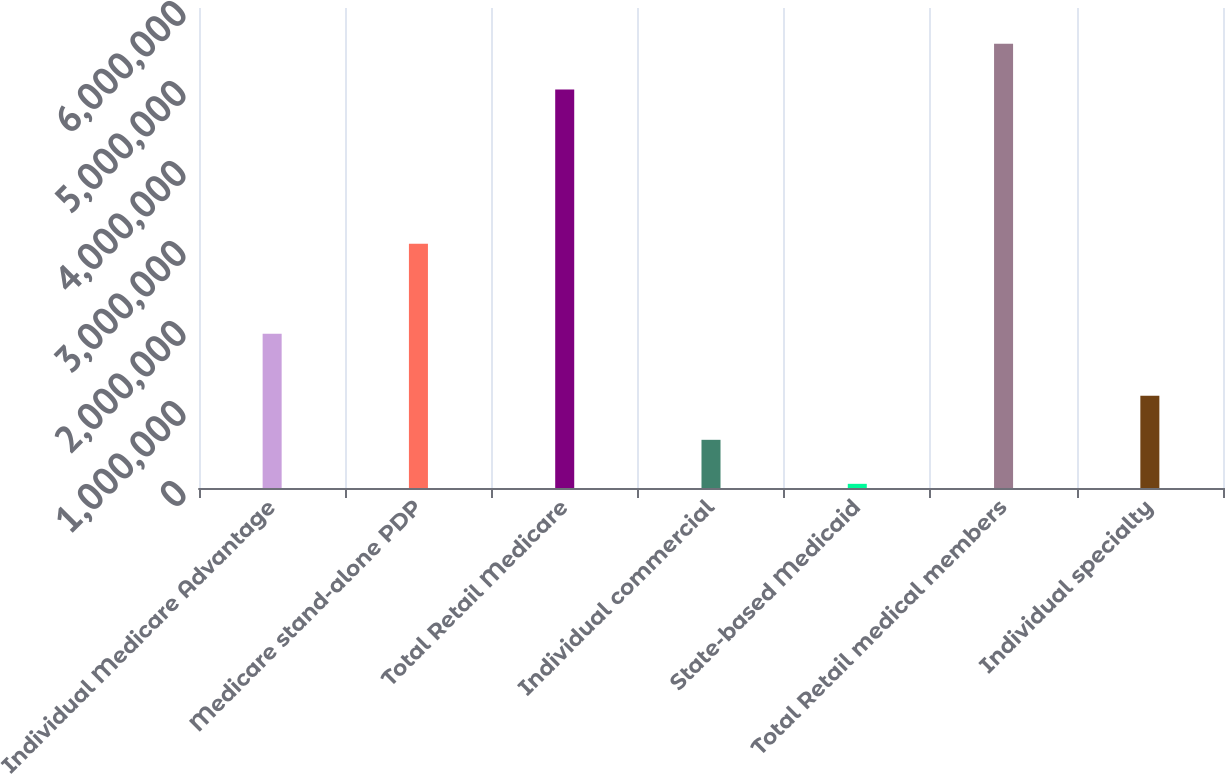Convert chart to OTSL. <chart><loc_0><loc_0><loc_500><loc_500><bar_chart><fcel>Individual Medicare Advantage<fcel>Medicare stand-alone PDP<fcel>Total Retail Medicare<fcel>Individual commercial<fcel>State-based Medicaid<fcel>Total Retail medical members<fcel>Individual specialty<nl><fcel>1.9276e+06<fcel>3.0527e+06<fcel>4.9803e+06<fcel>602270<fcel>52100<fcel>5.5538e+06<fcel>1.15244e+06<nl></chart> 